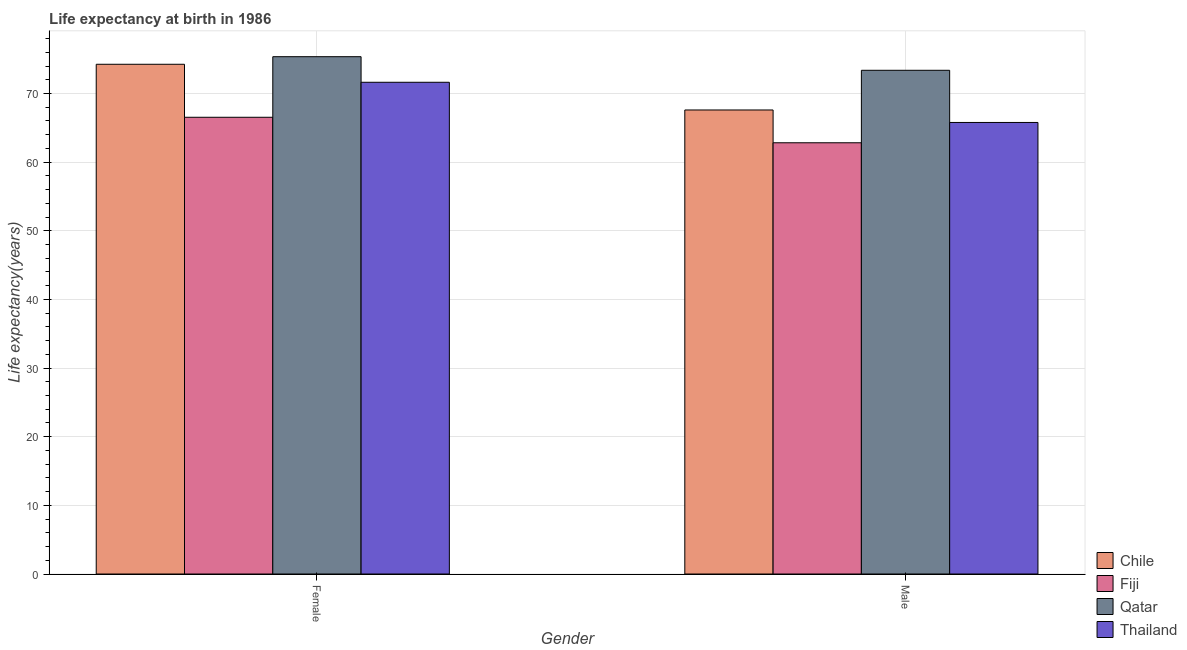How many groups of bars are there?
Give a very brief answer. 2. Are the number of bars per tick equal to the number of legend labels?
Your response must be concise. Yes. Are the number of bars on each tick of the X-axis equal?
Your response must be concise. Yes. How many bars are there on the 2nd tick from the left?
Provide a succinct answer. 4. How many bars are there on the 2nd tick from the right?
Make the answer very short. 4. What is the label of the 2nd group of bars from the left?
Ensure brevity in your answer.  Male. What is the life expectancy(female) in Thailand?
Your answer should be very brief. 71.63. Across all countries, what is the maximum life expectancy(male)?
Your response must be concise. 73.38. Across all countries, what is the minimum life expectancy(male)?
Offer a terse response. 62.82. In which country was the life expectancy(male) maximum?
Keep it short and to the point. Qatar. In which country was the life expectancy(male) minimum?
Keep it short and to the point. Fiji. What is the total life expectancy(female) in the graph?
Provide a succinct answer. 287.77. What is the difference between the life expectancy(male) in Fiji and that in Thailand?
Make the answer very short. -2.96. What is the difference between the life expectancy(female) in Chile and the life expectancy(male) in Qatar?
Provide a short and direct response. 0.88. What is the average life expectancy(female) per country?
Your answer should be very brief. 71.94. What is the difference between the life expectancy(female) and life expectancy(male) in Chile?
Provide a short and direct response. 6.66. In how many countries, is the life expectancy(male) greater than 40 years?
Give a very brief answer. 4. What is the ratio of the life expectancy(male) in Thailand to that in Qatar?
Your answer should be very brief. 0.9. Is the life expectancy(female) in Thailand less than that in Fiji?
Your answer should be compact. No. In how many countries, is the life expectancy(female) greater than the average life expectancy(female) taken over all countries?
Your answer should be very brief. 2. What does the 4th bar from the left in Female represents?
Provide a succinct answer. Thailand. What does the 3rd bar from the right in Male represents?
Ensure brevity in your answer.  Fiji. How many bars are there?
Offer a very short reply. 8. How many countries are there in the graph?
Offer a terse response. 4. Are the values on the major ticks of Y-axis written in scientific E-notation?
Ensure brevity in your answer.  No. Does the graph contain any zero values?
Provide a succinct answer. No. What is the title of the graph?
Offer a terse response. Life expectancy at birth in 1986. What is the label or title of the X-axis?
Provide a succinct answer. Gender. What is the label or title of the Y-axis?
Your answer should be compact. Life expectancy(years). What is the Life expectancy(years) in Chile in Female?
Offer a very short reply. 74.25. What is the Life expectancy(years) in Fiji in Female?
Ensure brevity in your answer.  66.53. What is the Life expectancy(years) in Qatar in Female?
Provide a short and direct response. 75.36. What is the Life expectancy(years) of Thailand in Female?
Give a very brief answer. 71.63. What is the Life expectancy(years) in Chile in Male?
Your response must be concise. 67.59. What is the Life expectancy(years) in Fiji in Male?
Ensure brevity in your answer.  62.82. What is the Life expectancy(years) of Qatar in Male?
Make the answer very short. 73.38. What is the Life expectancy(years) of Thailand in Male?
Offer a very short reply. 65.78. Across all Gender, what is the maximum Life expectancy(years) of Chile?
Provide a succinct answer. 74.25. Across all Gender, what is the maximum Life expectancy(years) of Fiji?
Offer a terse response. 66.53. Across all Gender, what is the maximum Life expectancy(years) in Qatar?
Provide a succinct answer. 75.36. Across all Gender, what is the maximum Life expectancy(years) in Thailand?
Your answer should be very brief. 71.63. Across all Gender, what is the minimum Life expectancy(years) in Chile?
Ensure brevity in your answer.  67.59. Across all Gender, what is the minimum Life expectancy(years) in Fiji?
Your response must be concise. 62.82. Across all Gender, what is the minimum Life expectancy(years) of Qatar?
Offer a terse response. 73.38. Across all Gender, what is the minimum Life expectancy(years) in Thailand?
Provide a succinct answer. 65.78. What is the total Life expectancy(years) of Chile in the graph?
Make the answer very short. 141.85. What is the total Life expectancy(years) in Fiji in the graph?
Provide a succinct answer. 129.35. What is the total Life expectancy(years) in Qatar in the graph?
Your answer should be very brief. 148.73. What is the total Life expectancy(years) in Thailand in the graph?
Give a very brief answer. 137.41. What is the difference between the Life expectancy(years) in Chile in Female and that in Male?
Your answer should be very brief. 6.66. What is the difference between the Life expectancy(years) of Fiji in Female and that in Male?
Make the answer very short. 3.71. What is the difference between the Life expectancy(years) in Qatar in Female and that in Male?
Your answer should be very brief. 1.98. What is the difference between the Life expectancy(years) of Thailand in Female and that in Male?
Make the answer very short. 5.85. What is the difference between the Life expectancy(years) in Chile in Female and the Life expectancy(years) in Fiji in Male?
Offer a very short reply. 11.44. What is the difference between the Life expectancy(years) in Chile in Female and the Life expectancy(years) in Qatar in Male?
Offer a terse response. 0.88. What is the difference between the Life expectancy(years) in Chile in Female and the Life expectancy(years) in Thailand in Male?
Keep it short and to the point. 8.48. What is the difference between the Life expectancy(years) in Fiji in Female and the Life expectancy(years) in Qatar in Male?
Ensure brevity in your answer.  -6.84. What is the difference between the Life expectancy(years) of Fiji in Female and the Life expectancy(years) of Thailand in Male?
Your answer should be compact. 0.76. What is the difference between the Life expectancy(years) of Qatar in Female and the Life expectancy(years) of Thailand in Male?
Ensure brevity in your answer.  9.58. What is the average Life expectancy(years) of Chile per Gender?
Give a very brief answer. 70.92. What is the average Life expectancy(years) in Fiji per Gender?
Offer a terse response. 64.67. What is the average Life expectancy(years) of Qatar per Gender?
Your response must be concise. 74.37. What is the average Life expectancy(years) of Thailand per Gender?
Your answer should be compact. 68.7. What is the difference between the Life expectancy(years) in Chile and Life expectancy(years) in Fiji in Female?
Your answer should be very brief. 7.72. What is the difference between the Life expectancy(years) in Chile and Life expectancy(years) in Qatar in Female?
Your response must be concise. -1.1. What is the difference between the Life expectancy(years) of Chile and Life expectancy(years) of Thailand in Female?
Your answer should be compact. 2.62. What is the difference between the Life expectancy(years) of Fiji and Life expectancy(years) of Qatar in Female?
Your answer should be very brief. -8.82. What is the difference between the Life expectancy(years) in Fiji and Life expectancy(years) in Thailand in Female?
Ensure brevity in your answer.  -5.1. What is the difference between the Life expectancy(years) in Qatar and Life expectancy(years) in Thailand in Female?
Your answer should be compact. 3.73. What is the difference between the Life expectancy(years) in Chile and Life expectancy(years) in Fiji in Male?
Offer a very short reply. 4.78. What is the difference between the Life expectancy(years) of Chile and Life expectancy(years) of Qatar in Male?
Your response must be concise. -5.78. What is the difference between the Life expectancy(years) of Chile and Life expectancy(years) of Thailand in Male?
Your answer should be compact. 1.82. What is the difference between the Life expectancy(years) in Fiji and Life expectancy(years) in Qatar in Male?
Provide a succinct answer. -10.56. What is the difference between the Life expectancy(years) in Fiji and Life expectancy(years) in Thailand in Male?
Your answer should be very brief. -2.96. What is the difference between the Life expectancy(years) in Qatar and Life expectancy(years) in Thailand in Male?
Provide a short and direct response. 7.6. What is the ratio of the Life expectancy(years) in Chile in Female to that in Male?
Give a very brief answer. 1.1. What is the ratio of the Life expectancy(years) in Fiji in Female to that in Male?
Your answer should be very brief. 1.06. What is the ratio of the Life expectancy(years) of Thailand in Female to that in Male?
Your answer should be compact. 1.09. What is the difference between the highest and the second highest Life expectancy(years) in Chile?
Provide a succinct answer. 6.66. What is the difference between the highest and the second highest Life expectancy(years) of Fiji?
Offer a very short reply. 3.71. What is the difference between the highest and the second highest Life expectancy(years) of Qatar?
Make the answer very short. 1.98. What is the difference between the highest and the second highest Life expectancy(years) in Thailand?
Offer a very short reply. 5.85. What is the difference between the highest and the lowest Life expectancy(years) of Chile?
Your response must be concise. 6.66. What is the difference between the highest and the lowest Life expectancy(years) in Fiji?
Make the answer very short. 3.71. What is the difference between the highest and the lowest Life expectancy(years) in Qatar?
Offer a very short reply. 1.98. What is the difference between the highest and the lowest Life expectancy(years) in Thailand?
Keep it short and to the point. 5.85. 